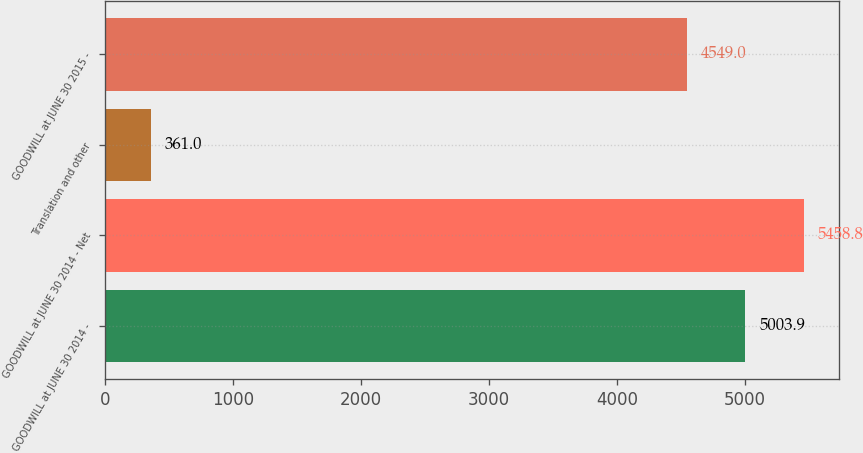Convert chart. <chart><loc_0><loc_0><loc_500><loc_500><bar_chart><fcel>GOODWILL at JUNE 30 2014 -<fcel>GOODWILL at JUNE 30 2014 - Net<fcel>Translation and other<fcel>GOODWILL at JUNE 30 2015 -<nl><fcel>5003.9<fcel>5458.8<fcel>361<fcel>4549<nl></chart> 